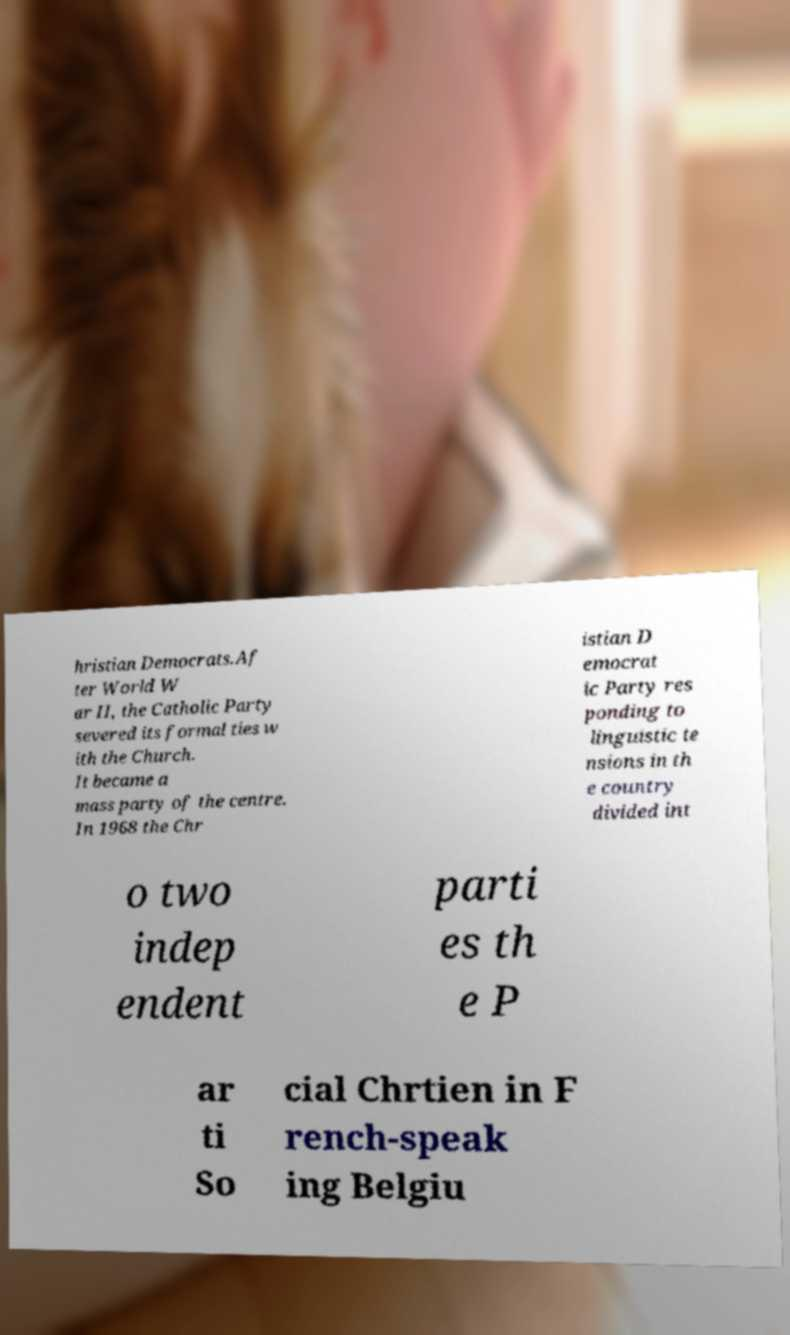I need the written content from this picture converted into text. Can you do that? hristian Democrats.Af ter World W ar II, the Catholic Party severed its formal ties w ith the Church. It became a mass party of the centre. In 1968 the Chr istian D emocrat ic Party res ponding to linguistic te nsions in th e country divided int o two indep endent parti es th e P ar ti So cial Chrtien in F rench-speak ing Belgiu 